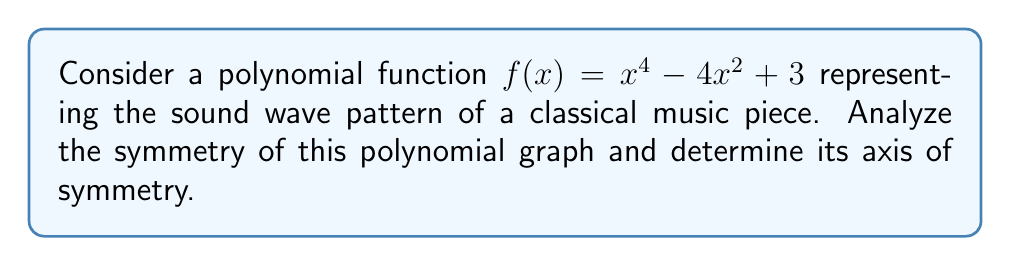Give your solution to this math problem. To analyze the symmetry of the polynomial graph, we'll follow these steps:

1. Identify the degree of the polynomial:
   The polynomial is of degree 4 (quartic).

2. Examine the terms:
   $f(x) = x^4 - 4x^2 + 3$
   All exponents are even (4 and 2), and there are no odd-degree terms.

3. Test for even function:
   For an even function, $f(x) = f(-x)$ for all $x$.
   $f(-x) = (-x)^4 - 4(-x)^2 + 3$
          $= x^4 - 4x^2 + 3$
          $= f(x)$

4. Determine axis of symmetry:
   Since $f(x) = f(-x)$, the function is even, and its graph is symmetric about the y-axis.

5. Verify y-axis as axis of symmetry:
   The equation of the y-axis is $x = 0$.

Therefore, the polynomial graph is symmetric about the y-axis $(x = 0)$.
Answer: $x = 0$ (y-axis) 